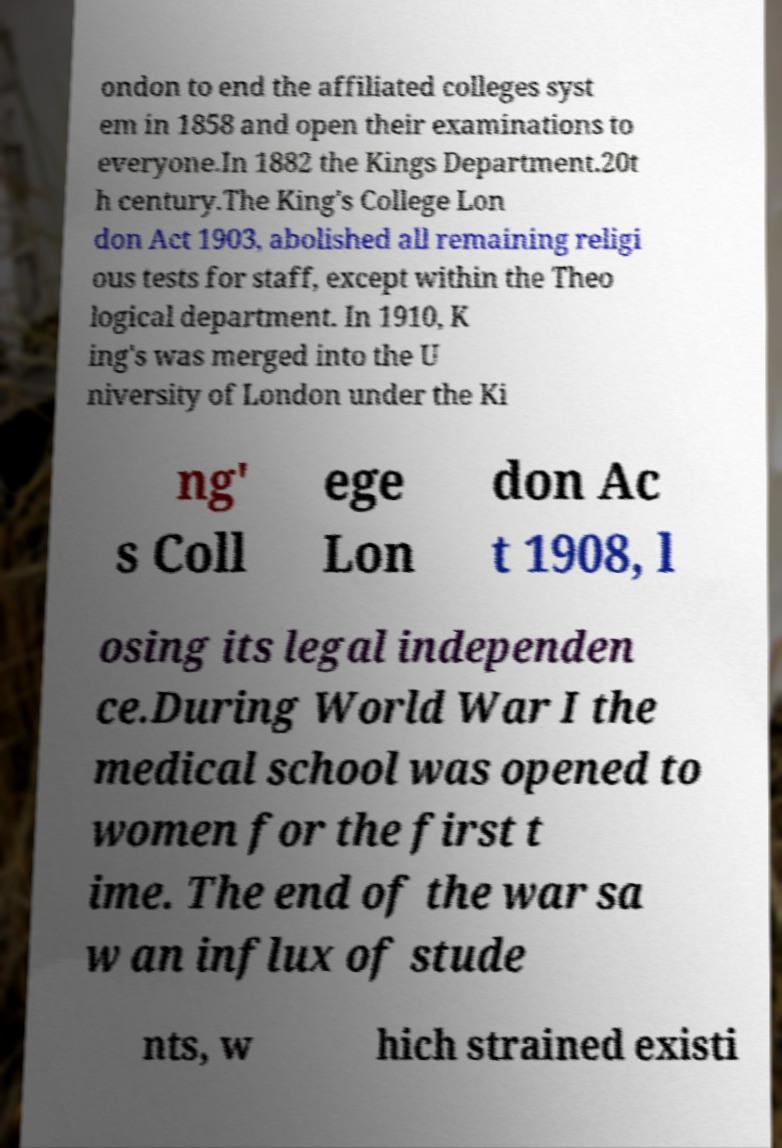Please read and relay the text visible in this image. What does it say? ondon to end the affiliated colleges syst em in 1858 and open their examinations to everyone.In 1882 the Kings Department.20t h century.The King's College Lon don Act 1903, abolished all remaining religi ous tests for staff, except within the Theo logical department. In 1910, K ing's was merged into the U niversity of London under the Ki ng' s Coll ege Lon don Ac t 1908, l osing its legal independen ce.During World War I the medical school was opened to women for the first t ime. The end of the war sa w an influx of stude nts, w hich strained existi 